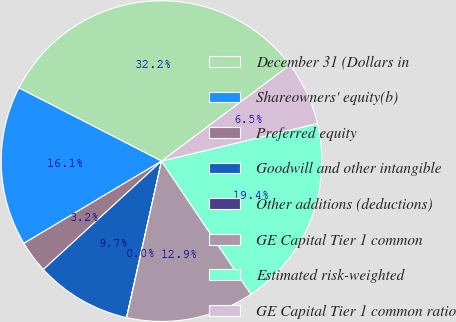Convert chart to OTSL. <chart><loc_0><loc_0><loc_500><loc_500><pie_chart><fcel>December 31 (Dollars in<fcel>Shareowners' equity(b)<fcel>Preferred equity<fcel>Goodwill and other intangible<fcel>Other additions (deductions)<fcel>GE Capital Tier 1 common<fcel>Estimated risk-weighted<fcel>GE Capital Tier 1 common ratio<nl><fcel>32.23%<fcel>16.12%<fcel>3.24%<fcel>9.68%<fcel>0.02%<fcel>12.9%<fcel>19.35%<fcel>6.46%<nl></chart> 